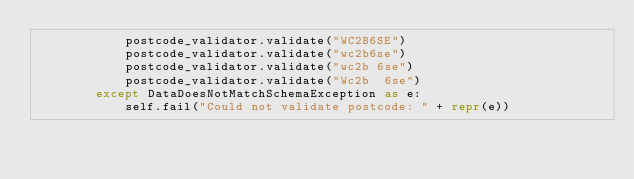<code> <loc_0><loc_0><loc_500><loc_500><_Python_>            postcode_validator.validate("WC2B6SE")
            postcode_validator.validate("wc2b6se")
            postcode_validator.validate("wc2b 6se")
            postcode_validator.validate("Wc2b  6se")
        except DataDoesNotMatchSchemaException as e:
            self.fail("Could not validate postcode: " + repr(e))
</code> 